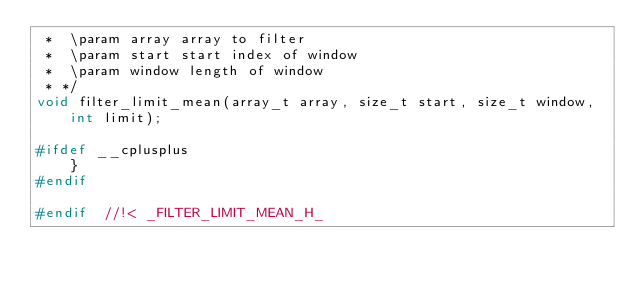Convert code to text. <code><loc_0><loc_0><loc_500><loc_500><_C_> *  \param array array to filter
 *  \param start start index of window
 *  \param window length of window
 * */
void filter_limit_mean(array_t array, size_t start, size_t window, int limit);

#ifdef __cplusplus
	}
#endif

#endif  //!< _FILTER_LIMIT_MEAN_H_

</code> 